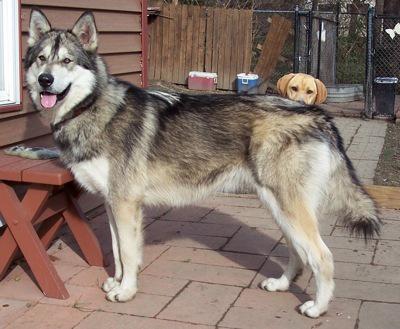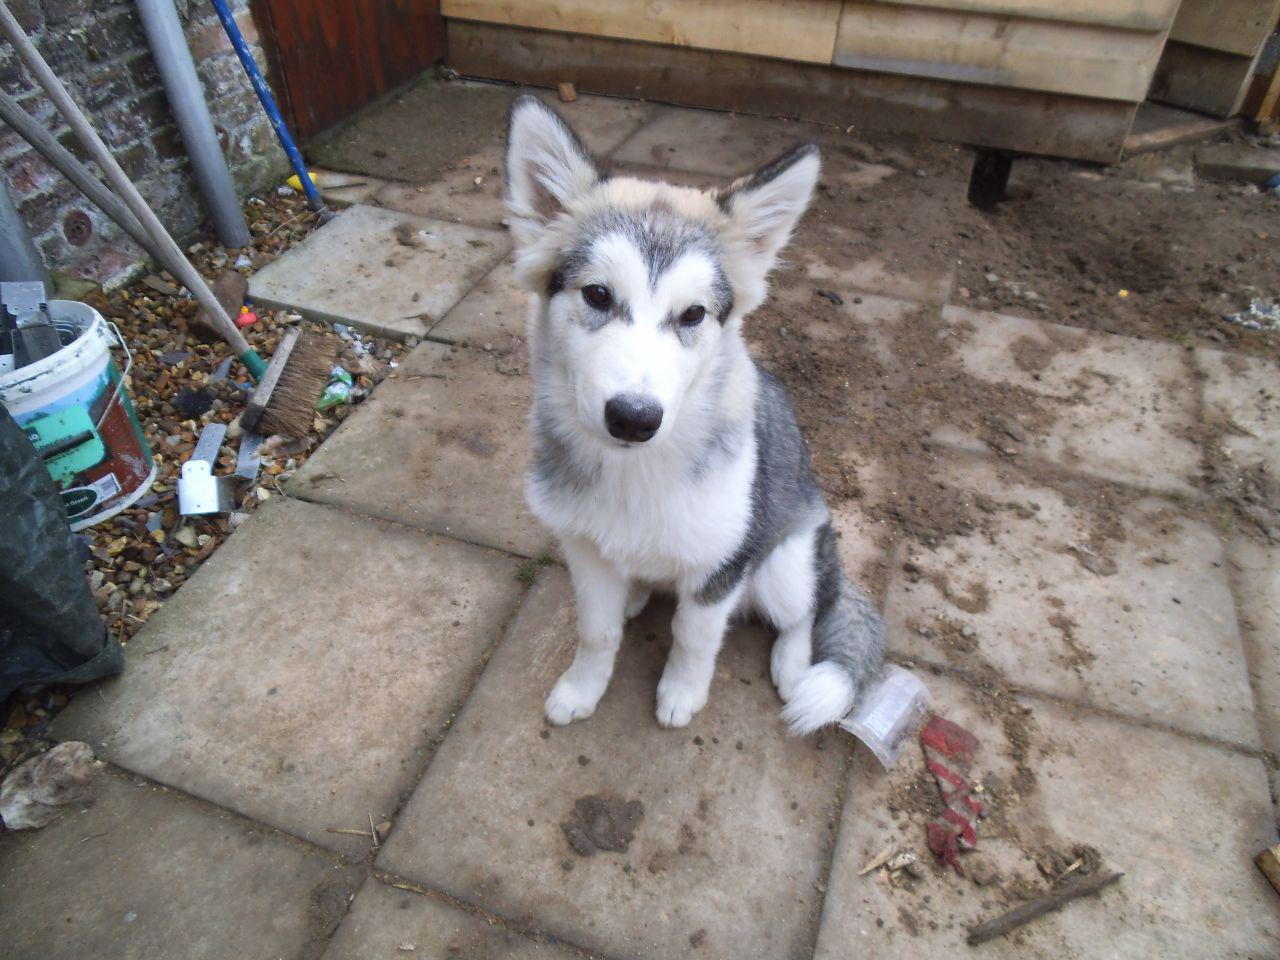The first image is the image on the left, the second image is the image on the right. For the images shown, is this caption "Neither of he images in the pair show an adult dog." true? Answer yes or no. No. The first image is the image on the left, the second image is the image on the right. Analyze the images presented: Is the assertion "Each image contains one husky pup with upright ears and muted fur coloring, and one image shows a puppy reclining with front paws extended on a mottled beige floor." valid? Answer yes or no. No. 